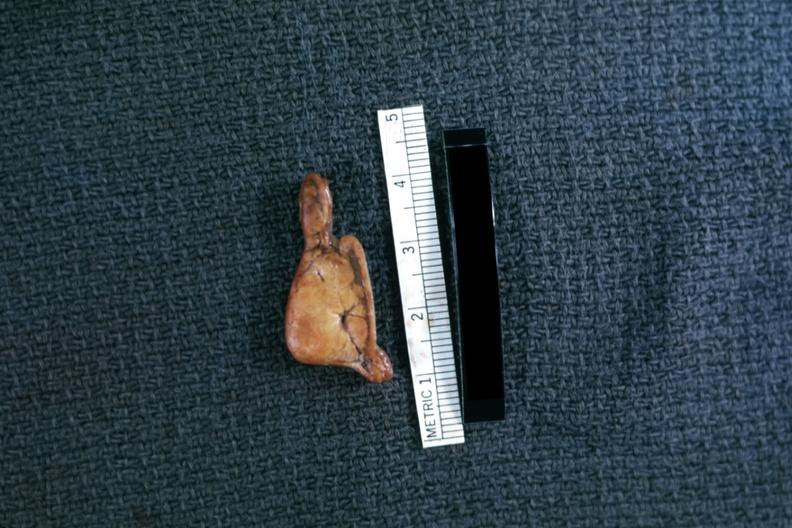what is present?
Answer the question using a single word or phrase. Cortical nodule 